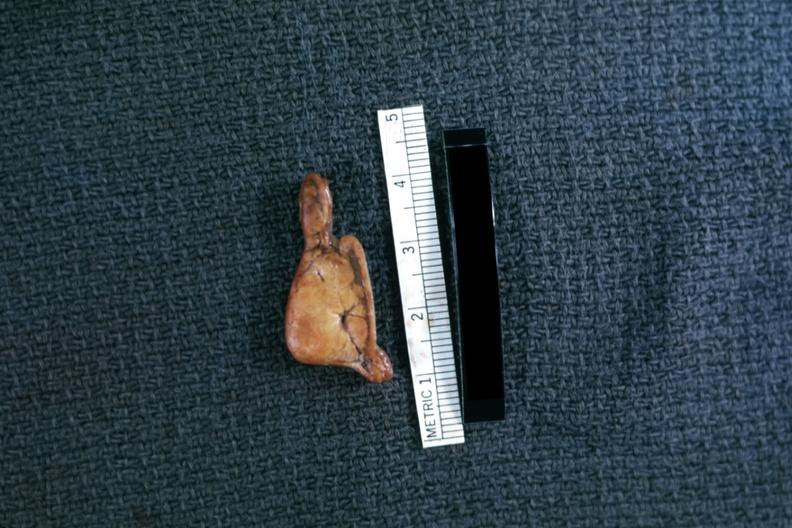what is present?
Answer the question using a single word or phrase. Cortical nodule 